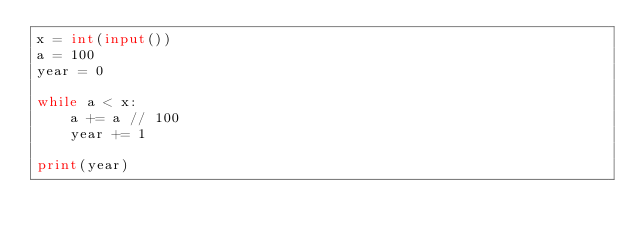<code> <loc_0><loc_0><loc_500><loc_500><_Python_>x = int(input())
a = 100
year = 0

while a < x:
    a += a // 100
    year += 1

print(year)</code> 